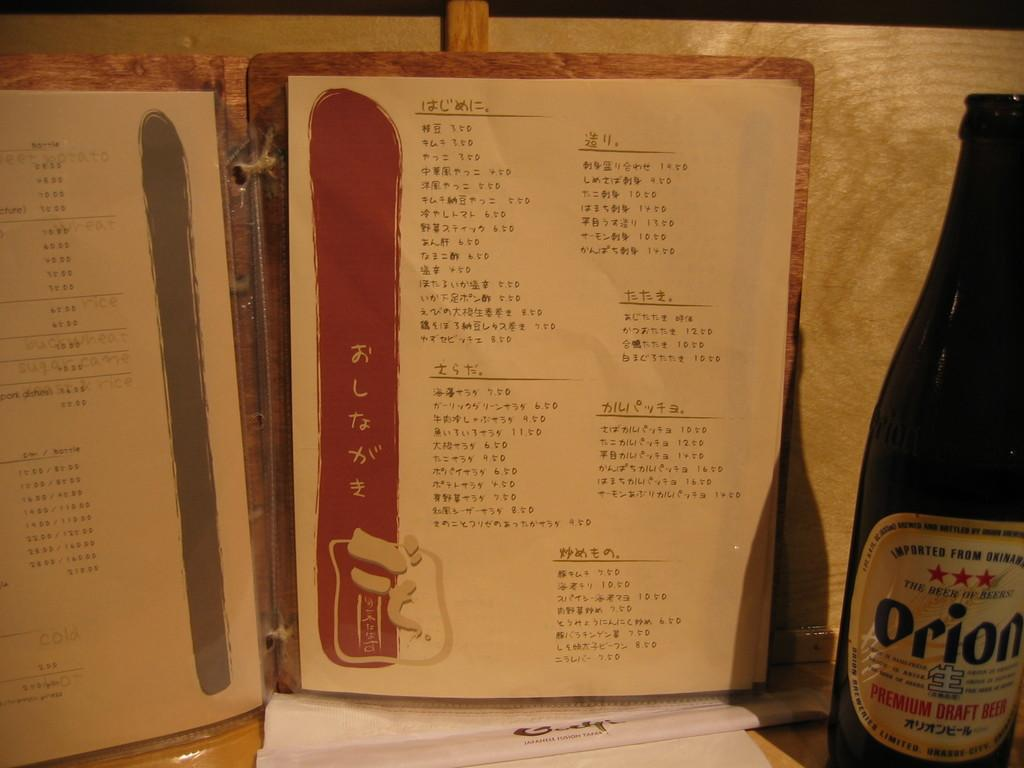Provide a one-sentence caption for the provided image. A bottle of Orion sits next to a paper written in a non-English language. 